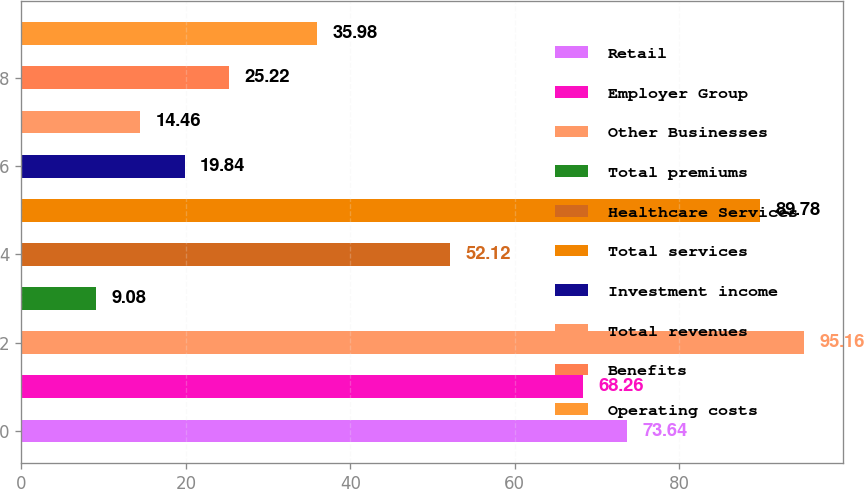Convert chart to OTSL. <chart><loc_0><loc_0><loc_500><loc_500><bar_chart><fcel>Retail<fcel>Employer Group<fcel>Other Businesses<fcel>Total premiums<fcel>Healthcare Services<fcel>Total services<fcel>Investment income<fcel>Total revenues<fcel>Benefits<fcel>Operating costs<nl><fcel>73.64<fcel>68.26<fcel>95.16<fcel>9.08<fcel>52.12<fcel>89.78<fcel>19.84<fcel>14.46<fcel>25.22<fcel>35.98<nl></chart> 